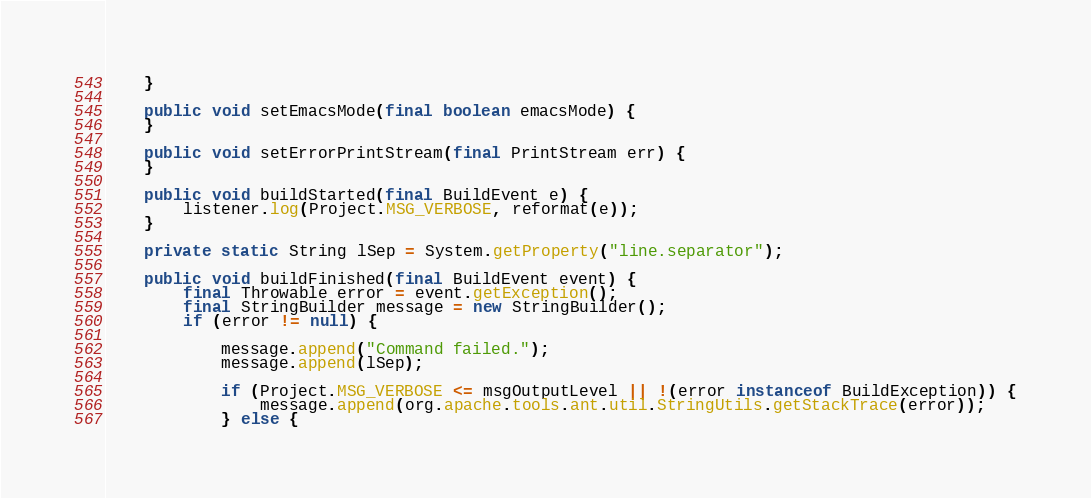Convert code to text. <code><loc_0><loc_0><loc_500><loc_500><_Java_>    }

    public void setEmacsMode(final boolean emacsMode) {
    }

    public void setErrorPrintStream(final PrintStream err) {
    }

    public void buildStarted(final BuildEvent e) {
        listener.log(Project.MSG_VERBOSE, reformat(e));
    }

    private static String lSep = System.getProperty("line.separator");

    public void buildFinished(final BuildEvent event) {
        final Throwable error = event.getException();
        final StringBuilder message = new StringBuilder();
        if (error != null) {

            message.append("Command failed.");
            message.append(lSep);

            if (Project.MSG_VERBOSE <= msgOutputLevel || !(error instanceof BuildException)) {
                message.append(org.apache.tools.ant.util.StringUtils.getStackTrace(error));
            } else {</code> 